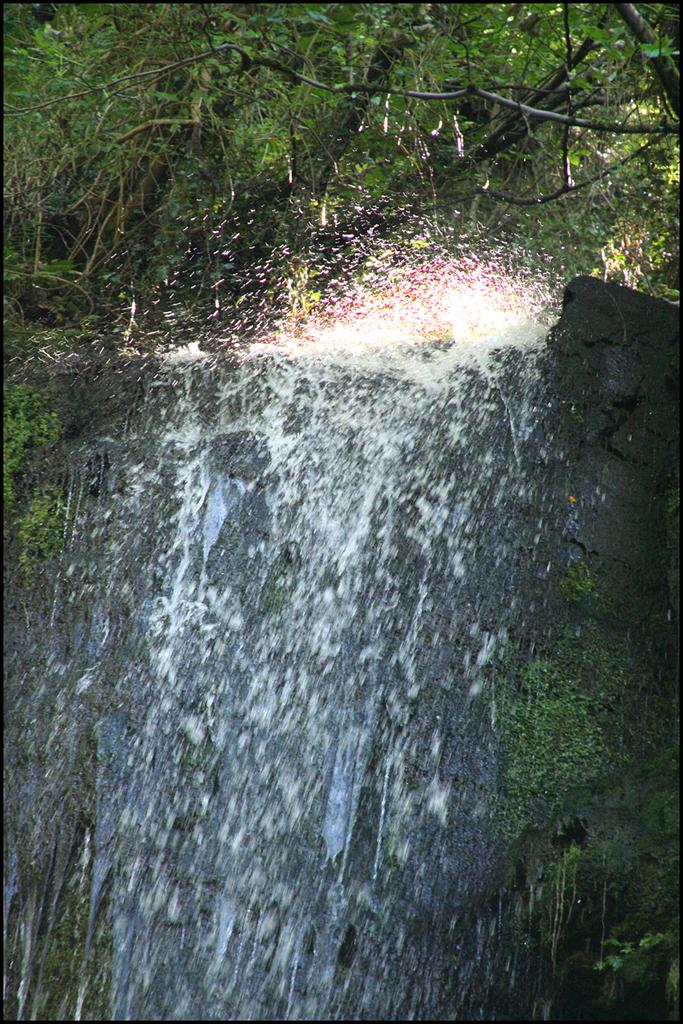What natural feature is the main subject of the image? There is a waterfall in the image. What can be seen in the background of the image? There are trees in the background of the image. What is the color of the trees in the image? The trees are green in color. Where is the dad sitting with his rabbit in the image? There is no dad or rabbit present in the image; it features a waterfall and green trees in the background. 